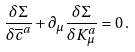Convert formula to latex. <formula><loc_0><loc_0><loc_500><loc_500>\frac { \delta \Sigma } { \delta \overline { c } ^ { a } } + \partial _ { \mu } \frac { \delta \Sigma } { \delta K _ { \mu } ^ { a } } = 0 \, .</formula> 